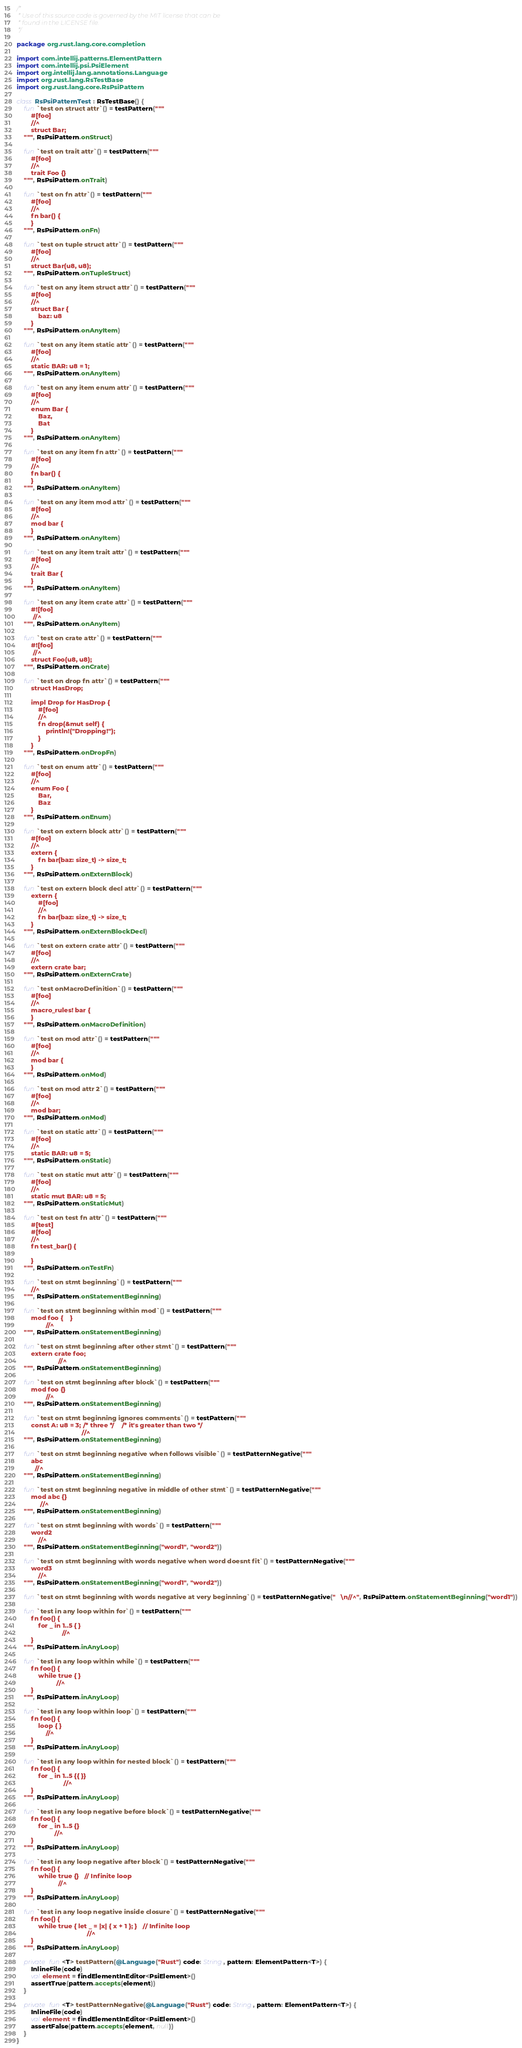<code> <loc_0><loc_0><loc_500><loc_500><_Kotlin_>/*
 * Use of this source code is governed by the MIT license that can be
 * found in the LICENSE file.
 */

package org.rust.lang.core.completion

import com.intellij.patterns.ElementPattern
import com.intellij.psi.PsiElement
import org.intellij.lang.annotations.Language
import org.rust.lang.RsTestBase
import org.rust.lang.core.RsPsiPattern

class RsPsiPatternTest : RsTestBase() {
    fun `test on struct attr`() = testPattern("""
        #[foo]
        //^
        struct Bar;
    """, RsPsiPattern.onStruct)

    fun `test on trait attr`() = testPattern("""
        #[foo]
        //^
        trait Foo {}
    """, RsPsiPattern.onTrait)

    fun `test on fn attr`() = testPattern("""
        #[foo]
        //^
        fn bar() {
        }
    """, RsPsiPattern.onFn)

    fun `test on tuple struct attr`() = testPattern("""
        #[foo]
        //^
        struct Bar(u8, u8);
    """, RsPsiPattern.onTupleStruct)

    fun `test on any item struct attr`() = testPattern("""
        #[foo]
        //^
        struct Bar {
            baz: u8
        }
    """, RsPsiPattern.onAnyItem)

    fun `test on any item static attr`() = testPattern("""
        #[foo]
        //^
        static BAR: u8 = 1;
    """, RsPsiPattern.onAnyItem)

    fun `test on any item enum attr`() = testPattern("""
        #[foo]
        //^
        enum Bar {
            Baz,
            Bat
        }
    """, RsPsiPattern.onAnyItem)

    fun `test on any item fn attr`() = testPattern("""
        #[foo]
        //^
        fn bar() {
        }
    """, RsPsiPattern.onAnyItem)

    fun `test on any item mod attr`() = testPattern("""
        #[foo]
        //^
        mod bar {
        }
    """, RsPsiPattern.onAnyItem)

    fun `test on any item trait attr`() = testPattern("""
        #[foo]
        //^
        trait Bar {
        }
    """, RsPsiPattern.onAnyItem)

    fun `test on any item crate attr`() = testPattern("""
        #![foo]
         //^
    """, RsPsiPattern.onAnyItem)

    fun `test on crate attr`() = testPattern("""
        #![foo]
         //^
        struct Foo(u8, u8);
    """, RsPsiPattern.onCrate)

    fun `test on drop fn attr`() = testPattern("""
        struct HasDrop;

        impl Drop for HasDrop {
            #[foo]
            //^
            fn drop(&mut self) {
                println!("Dropping!");
            }
        }
    """, RsPsiPattern.onDropFn)

    fun `test on enum attr`() = testPattern("""
        #[foo]
        //^
        enum Foo {
            Bar,
            Baz
        }
    """, RsPsiPattern.onEnum)

    fun `test on extern block attr`() = testPattern("""
        #[foo]
        //^
        extern {
            fn bar(baz: size_t) -> size_t;
        }
    """, RsPsiPattern.onExternBlock)

    fun `test on extern block decl attr`() = testPattern("""
        extern {
            #[foo]
            //^
            fn bar(baz: size_t) -> size_t;
        }
    """, RsPsiPattern.onExternBlockDecl)

    fun `test on extern crate attr`() = testPattern("""
        #[foo]
        //^
        extern crate bar;
    """, RsPsiPattern.onExternCrate)

    fun `test onMacroDefinition`() = testPattern("""
        #[foo]
        //^
        macro_rules! bar {
        }
    """, RsPsiPattern.onMacroDefinition)

    fun `test on mod attr`() = testPattern("""
        #[foo]
        //^
        mod bar {
        }
    """, RsPsiPattern.onMod)

    fun `test on mod attr 2`() = testPattern("""
        #[foo]
        //^
        mod bar;
    """, RsPsiPattern.onMod)

    fun `test on static attr`() = testPattern("""
        #[foo]
        //^
        static BAR: u8 = 5;
    """, RsPsiPattern.onStatic)

    fun `test on static mut attr`() = testPattern("""
        #[foo]
        //^
        static mut BAR: u8 = 5;
    """, RsPsiPattern.onStaticMut)

    fun `test on test fn attr`() = testPattern("""
        #[test]
        #[foo]
        //^
        fn test_bar() {

        }
    """, RsPsiPattern.onTestFn)

    fun `test on stmt beginning`() = testPattern("""
        //^
    """, RsPsiPattern.onStatementBeginning)

    fun `test on stmt beginning within mod`() = testPattern("""
        mod foo {    }
                //^
    """, RsPsiPattern.onStatementBeginning)

    fun `test on stmt beginning after other stmt`() = testPattern("""
        extern crate foo;
                       //^
    """, RsPsiPattern.onStatementBeginning)

    fun `test on stmt beginning after block`() = testPattern("""
        mod foo {}
                //^
    """, RsPsiPattern.onStatementBeginning)

    fun `test on stmt beginning ignores comments`() = testPattern("""
        const A: u8 = 3; /* three */    /* it's greater than two */
                                    //^
    """, RsPsiPattern.onStatementBeginning)

    fun `test on stmt beginning negative when follows visible`() = testPatternNegative("""
        abc
          //^
    """, RsPsiPattern.onStatementBeginning)

    fun `test on stmt beginning negative in middle of other stmt`() = testPatternNegative("""
        mod abc {}
             //^
    """, RsPsiPattern.onStatementBeginning)

    fun `test on stmt beginning with words`() = testPattern("""
        word2
            //^
    """, RsPsiPattern.onStatementBeginning("word1", "word2"))

    fun `test on stmt beginning with words negative when word doesnt fit`() = testPatternNegative("""
        word3
            //^
    """, RsPsiPattern.onStatementBeginning("word1", "word2"))

    fun `test on stmt beginning with words negative at very beginning`() = testPatternNegative("   \n//^", RsPsiPattern.onStatementBeginning("word1"))

    fun `test in any loop within for`() = testPattern("""
        fn foo() {
            for _ in 1..5 { }
                         //^
        }
    """, RsPsiPattern.inAnyLoop)

    fun `test in any loop within while`() = testPattern("""
        fn foo() {
            while true { }
                      //^
        }
    """, RsPsiPattern.inAnyLoop)

    fun `test in any loop within loop`() = testPattern("""
        fn foo() {
            loop { }
                //^
        }
    """, RsPsiPattern.inAnyLoop)

    fun `test in any loop within for nested block`() = testPattern("""
        fn foo() {
            for _ in 1..5 {{ }}
                          //^
        }
    """, RsPsiPattern.inAnyLoop)

    fun `test in any loop negative before block`() = testPatternNegative("""
        fn foo() {
            for _ in 1..5 {}
                     //^
        }
    """, RsPsiPattern.inAnyLoop)

    fun `test in any loop negative after block`() = testPatternNegative("""
        fn foo() {
            while true {}   // Infinite loop
                       //^
        }
    """, RsPsiPattern.inAnyLoop)

    fun `test in any loop negative inside closure`() = testPatternNegative("""
        fn foo() {
            while true { let _ = |x| { x + 1 }; }   // Infinite loop
                                       //^
        }
    """, RsPsiPattern.inAnyLoop)

    private fun <T> testPattern(@Language("Rust") code: String, pattern: ElementPattern<T>) {
        InlineFile(code)
        val element = findElementInEditor<PsiElement>()
        assertTrue(pattern.accepts(element))
    }

    private fun <T> testPatternNegative(@Language("Rust") code: String, pattern: ElementPattern<T>) {
        InlineFile(code)
        val element = findElementInEditor<PsiElement>()
        assertFalse(pattern.accepts(element, null))
    }
}
</code> 